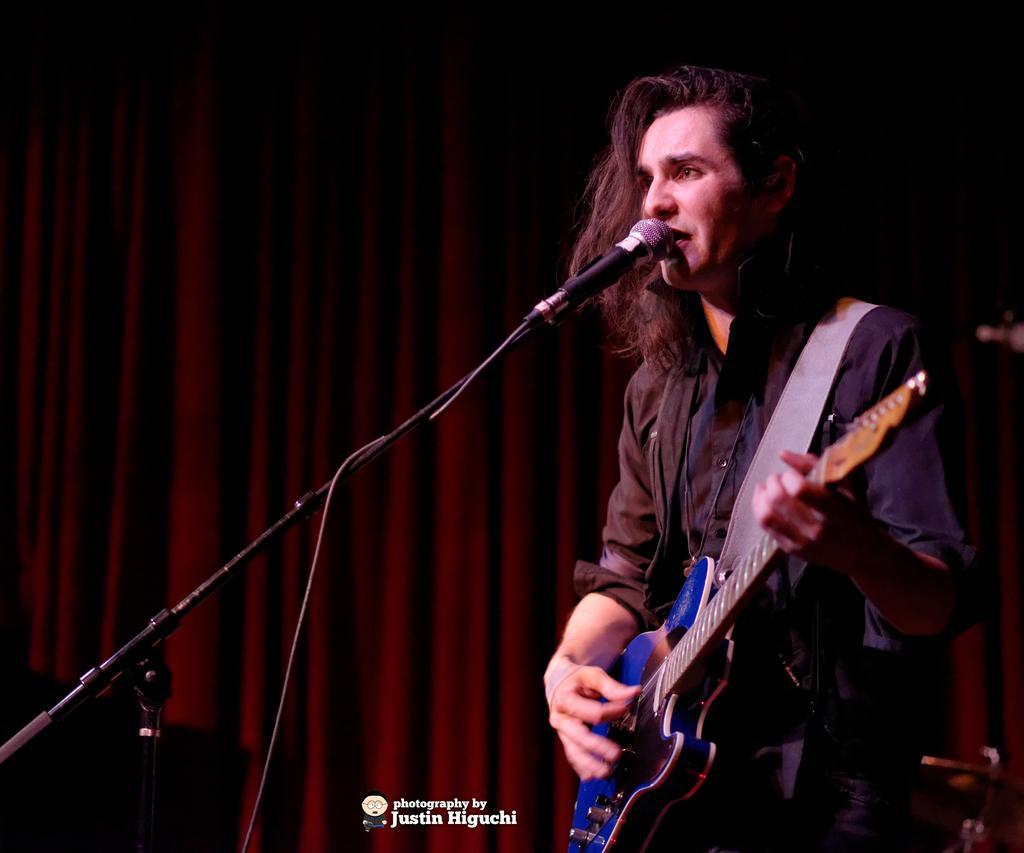Please provide a concise description of this image. In this picture we can see a person is playing guitar in front of microphone, in the background there is curtains. 